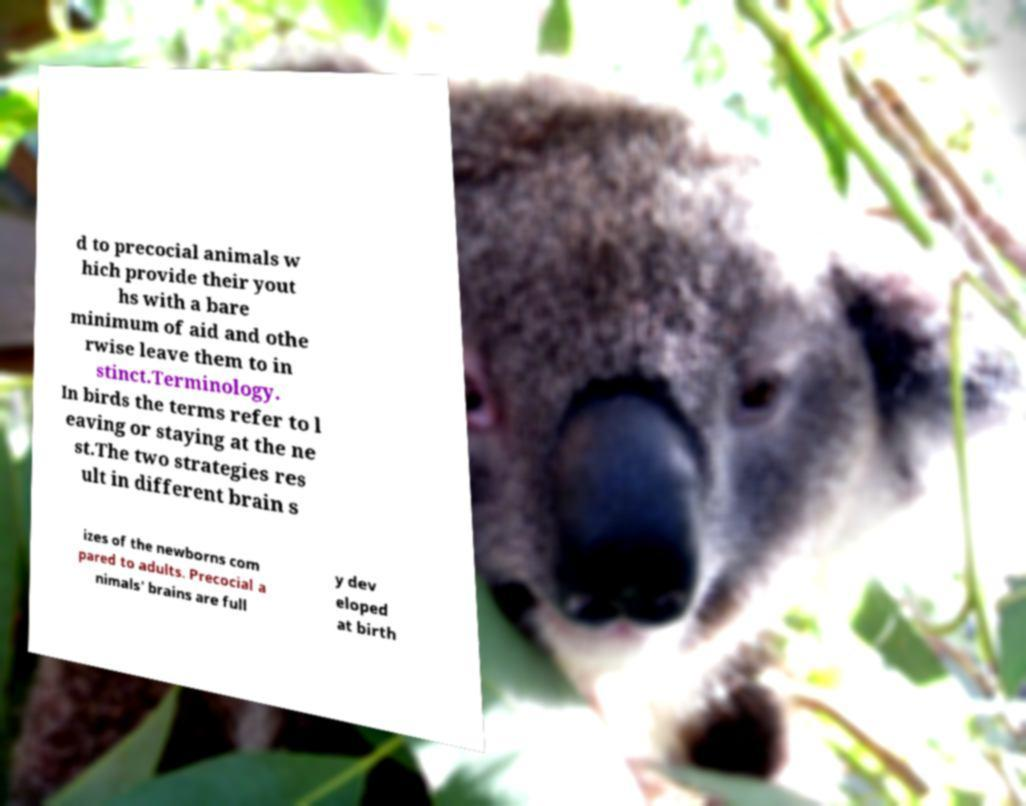Can you accurately transcribe the text from the provided image for me? d to precocial animals w hich provide their yout hs with a bare minimum of aid and othe rwise leave them to in stinct.Terminology. In birds the terms refer to l eaving or staying at the ne st.The two strategies res ult in different brain s izes of the newborns com pared to adults. Precocial a nimals' brains are full y dev eloped at birth 